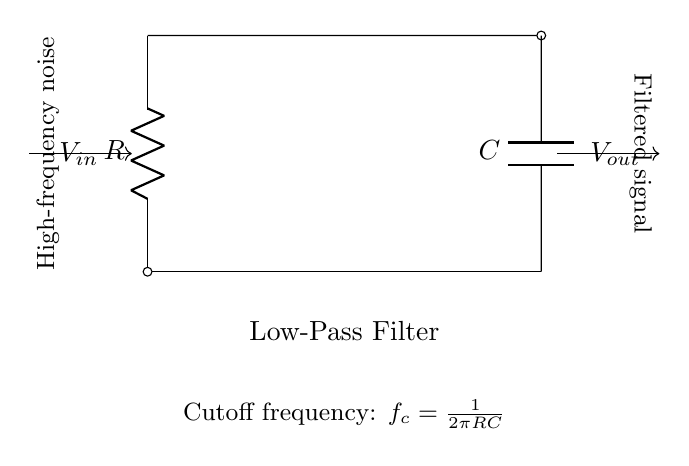What are the two main components shown in the circuit? The circuit includes a resistor and a capacitor, which are depicted as R and C respectively in the diagram. Both components are essential for the functioning of the low-pass filter.
Answer: Resistor and capacitor What is the function of this circuit? This circuit serves to reduce high-frequency noise, allowing only lower frequencies to pass through, which is a common requirement in studio equipment to improve the quality of the signal.
Answer: Filter high-frequency noise What is the output voltage denoted as in the diagram? The output voltage, which is the voltage after filtering, is denoted as Vout in the circuit diagram, showing the result of the filter's operation.
Answer: Vout What is the cutoff frequency formula for this filter? The cutoff frequency is expressed with the formula f_c equals one over two pi RC, reflecting the relationship between the resistor and capacitor values in determining the filtering effect.
Answer: f_c = 1 / 2πRC How does increasing the resistance affect the cutoff frequency? Increasing the resistance will lead to a decrease in the cutoff frequency, as the formula shows an inverse relationship between resistance and cutoff frequency, thereby allowing lower frequencies to pass through while filtering out high frequencies more effectively.
Answer: Cutoff frequency decreases What direction does the filtered signal travel toward? The filtered signal is indicated to travel from the output point, Vout, toward the right, suggesting that it is directed towards the subsequent stage or output in the equipment.
Answer: Right What does the notation R signify in the diagram? The notation R represents the resistor in the circuit, which is a fundamental component that restricts current flow and plays a critical role in determining the filter's behavior alongside the capacitor.
Answer: Resistor 